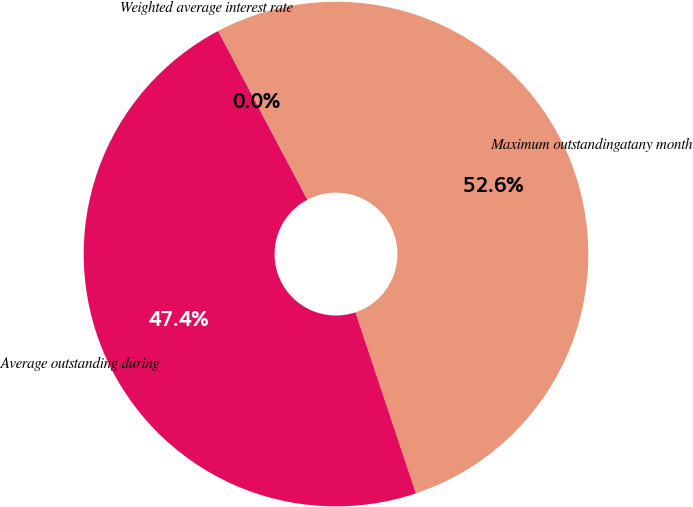<chart> <loc_0><loc_0><loc_500><loc_500><pie_chart><fcel>Maximum outstandingatany month<fcel>Average outstanding during<fcel>Weighted average interest rate<nl><fcel>52.6%<fcel>47.39%<fcel>0.01%<nl></chart> 